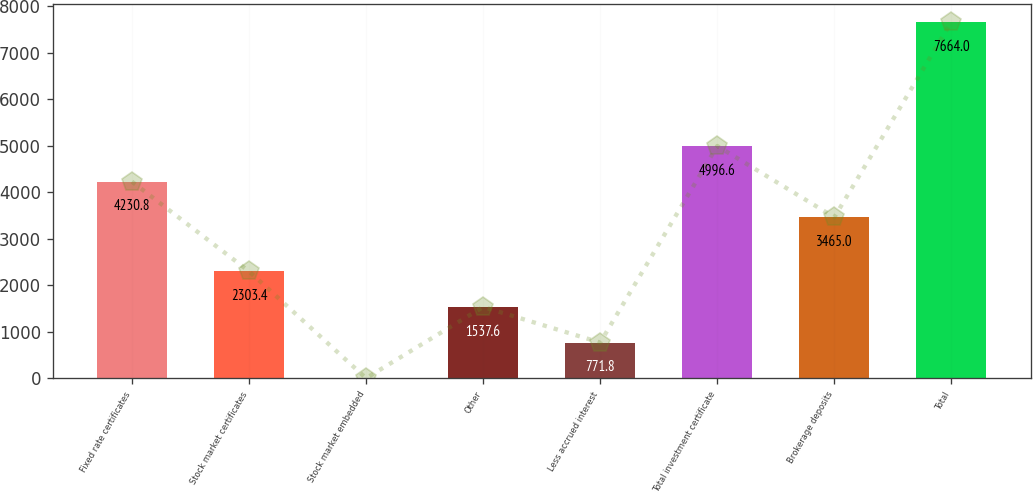Convert chart to OTSL. <chart><loc_0><loc_0><loc_500><loc_500><bar_chart><fcel>Fixed rate certificates<fcel>Stock market certificates<fcel>Stock market embedded<fcel>Other<fcel>Less accrued interest<fcel>Total investment certificate<fcel>Brokerage deposits<fcel>Total<nl><fcel>4230.8<fcel>2303.4<fcel>6<fcel>1537.6<fcel>771.8<fcel>4996.6<fcel>3465<fcel>7664<nl></chart> 